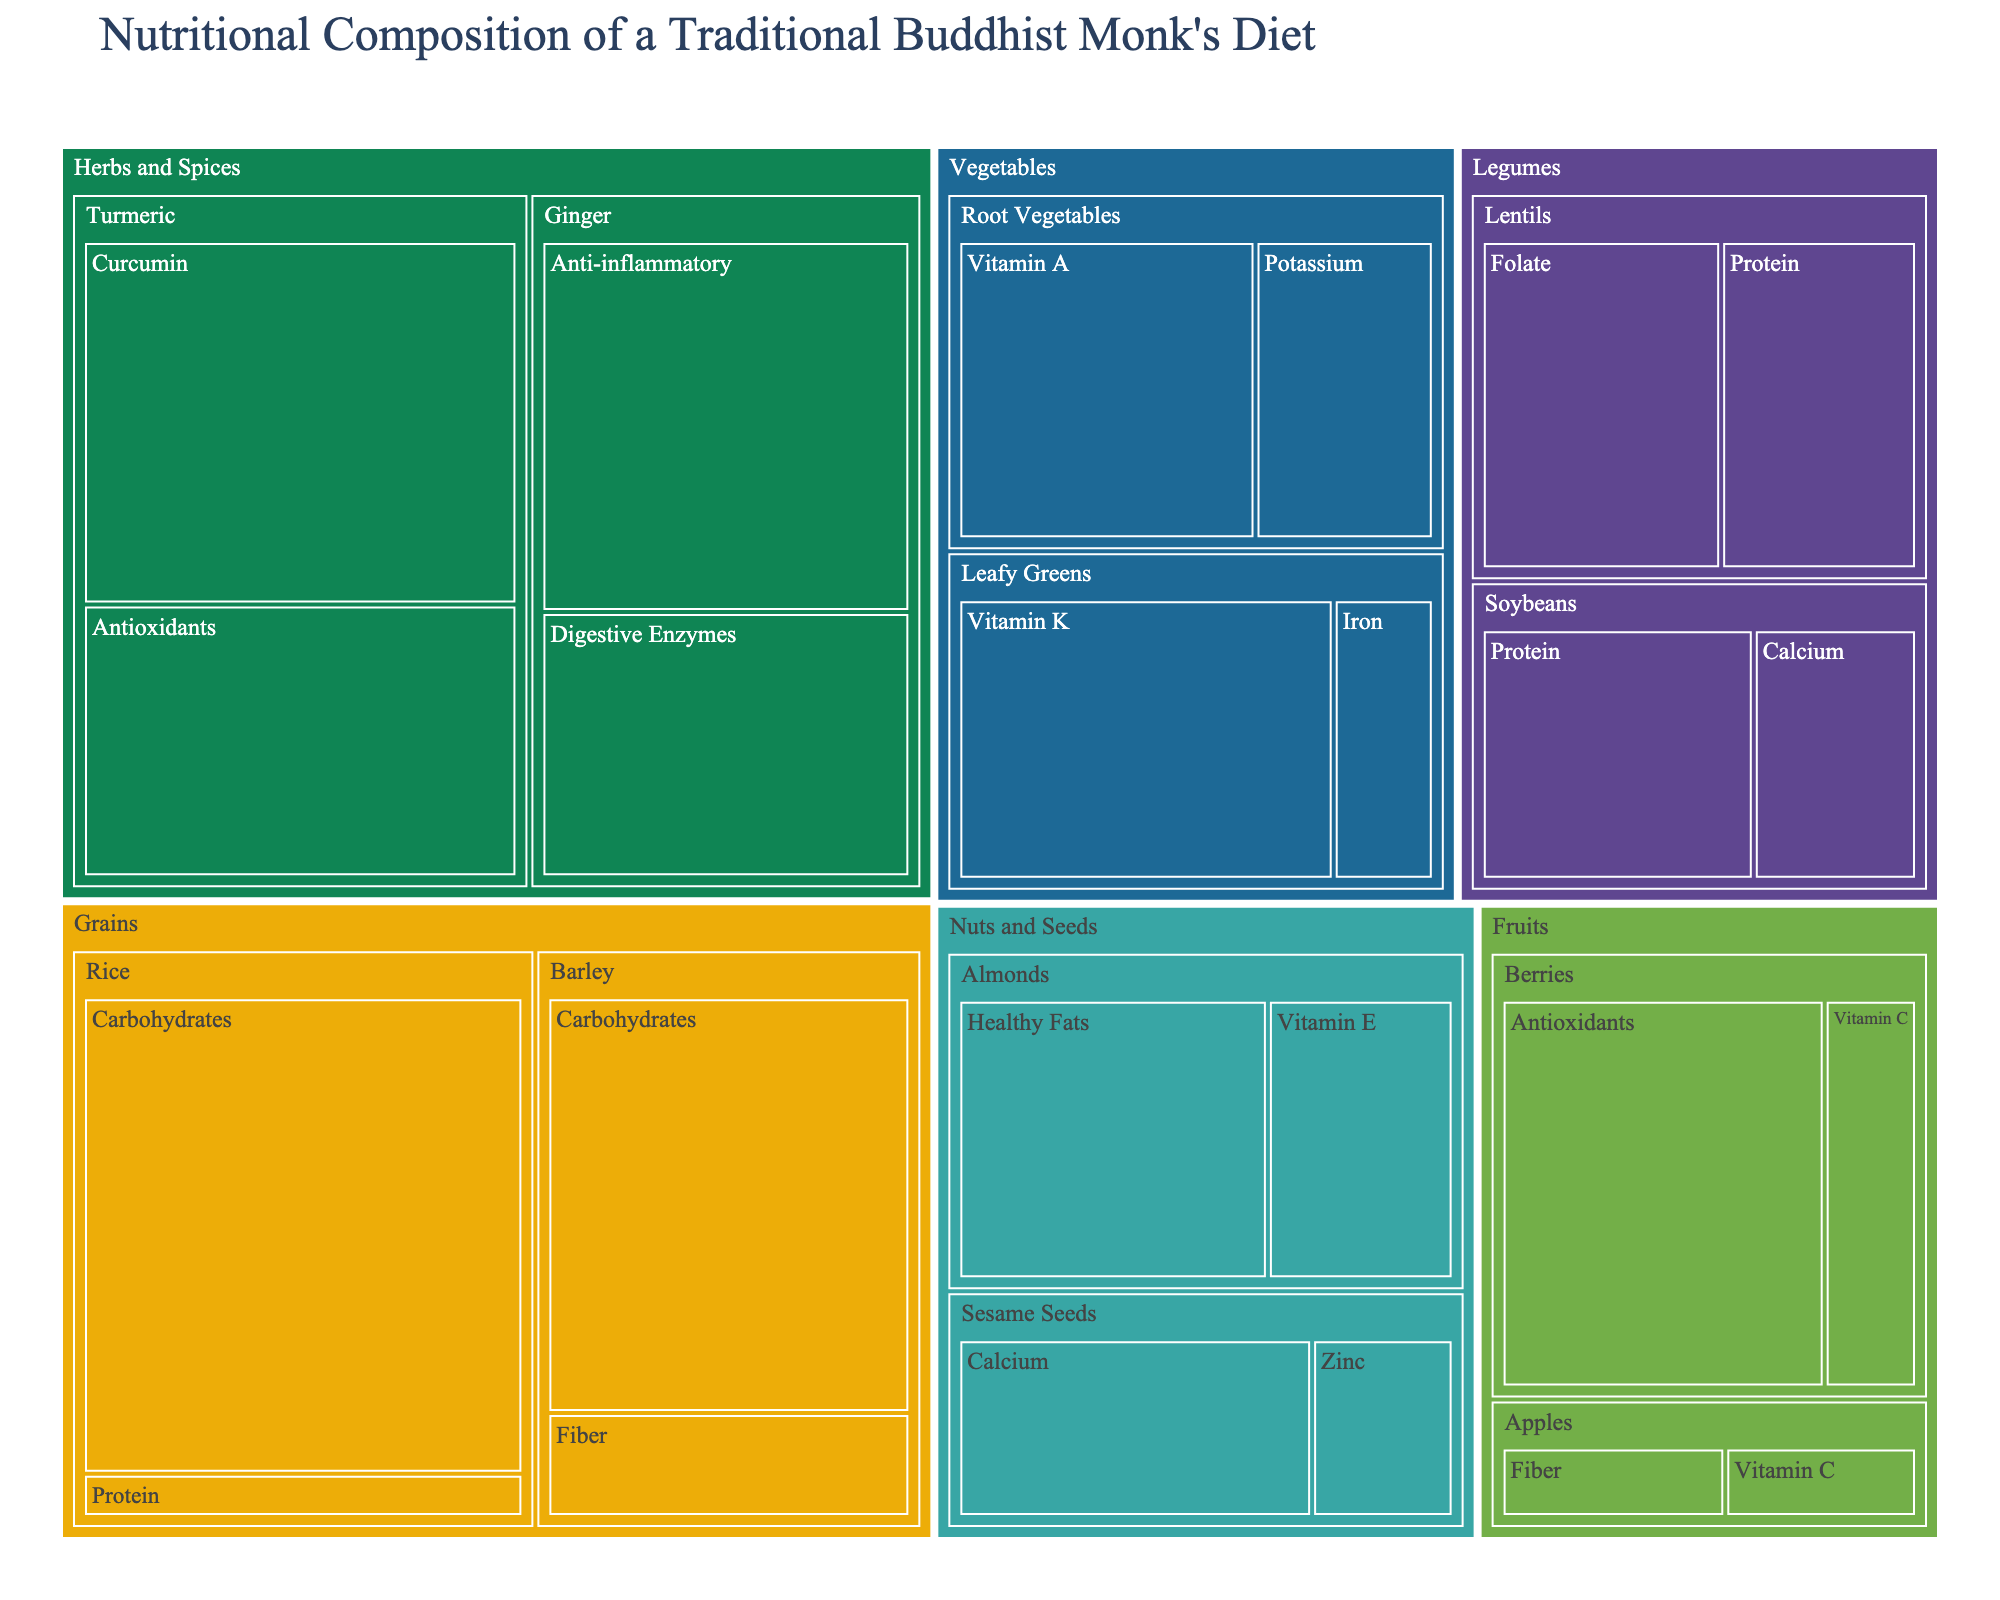What is the title of the treemap? The title of the treemap is shown at the top of the figure, which provides insight into what the data represents.
Answer: Nutritional Composition of a Traditional Buddhist Monk's Diet Which nutrient has the highest value in the 'Grains' food group? Within the 'Grains' food group, the nutrient with the highest value is found by identifying the largest area in that specific section of the treemap.
Answer: Carbohydrates in Rice (55) How does the value of Vitamin C in Berries compare to that in Apples? Identify the sections for Berries and Apples under the 'Fruits' food group and compare the sizes of the areas representing Vitamin C.
Answer: Berries (10) have a higher Vitamin C value than Apples (6) What is the combined value of Protein in the 'Grains' and 'Legumes' food groups? Locate the nutrients labeled 'Protein' under both 'Grains' and 'Legumes'. Add the values together to find the combined total.
Answer: 5 (Rice) + 20 (Soybeans) + 18 (Lentils) = 43 Which food group contains the most diverse set of nutrients? Review the treemap and count the unique nutrients listed within each food group. The food group with the highest count has the most diverse set of nutrients.
Answer: Herbs and Spices (Curcumin, Antioxidants, Anti-inflammatory, Digestive Enzymes) What is the value of Fiber in the 'Grains' food group, and which specific category does it come from? Find the 'Fiber' nutrient within the 'Grains' food group on the treemap and note its value and the specific category it belongs to.
Answer: 10, Barley Compare the value of Calcium in Soybeans and Sesame Seeds. Which has a higher value? Identify the areas representing Calcium values within the 'Legumes' and 'Nuts and Seeds' groups for Soybeans and Sesame Seeds, then compare their sizes.
Answer: Sesame Seeds (20) Which nutrient has the highest value in the 'Herbs and Spices' food group? Within the 'Herbs and Spices' food group, identify the nutrient with the largest area in the treemap.
Answer: Curcumin in Turmeric (40) What is the total value of Antioxidants found in the monk's diet? Locate all instances of the 'Antioxidants' nutrient in the treemap and sum their values.
Answer: 35 (Berries) + 30 (Turmeric) = 65 